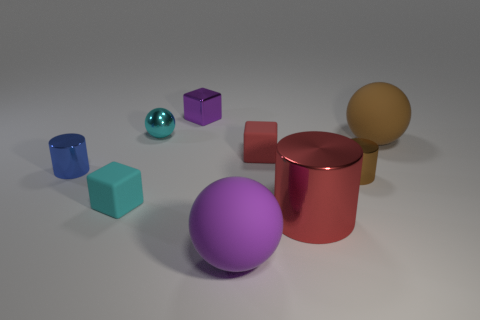Add 1 big yellow cylinders. How many objects exist? 10 Subtract all balls. How many objects are left? 6 Add 9 brown metallic cylinders. How many brown metallic cylinders are left? 10 Add 1 tiny cyan blocks. How many tiny cyan blocks exist? 2 Subtract 1 purple spheres. How many objects are left? 8 Subtract all big shiny things. Subtract all big red metal cylinders. How many objects are left? 7 